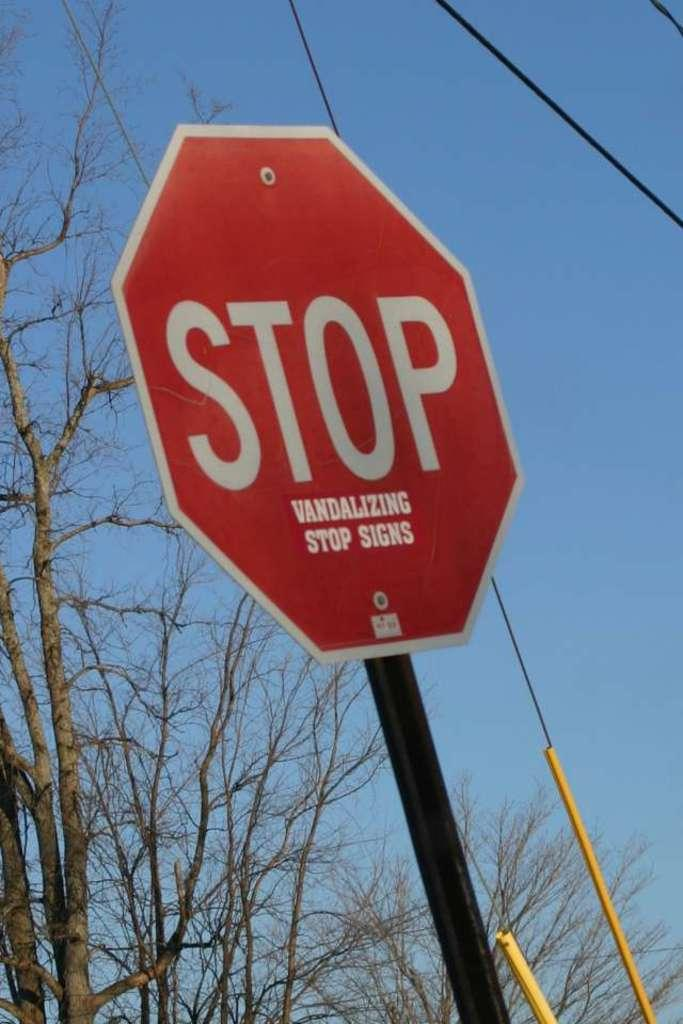<image>
Relay a brief, clear account of the picture shown. A red stop says has a sticker on it that says Vandalizing stop signs. 